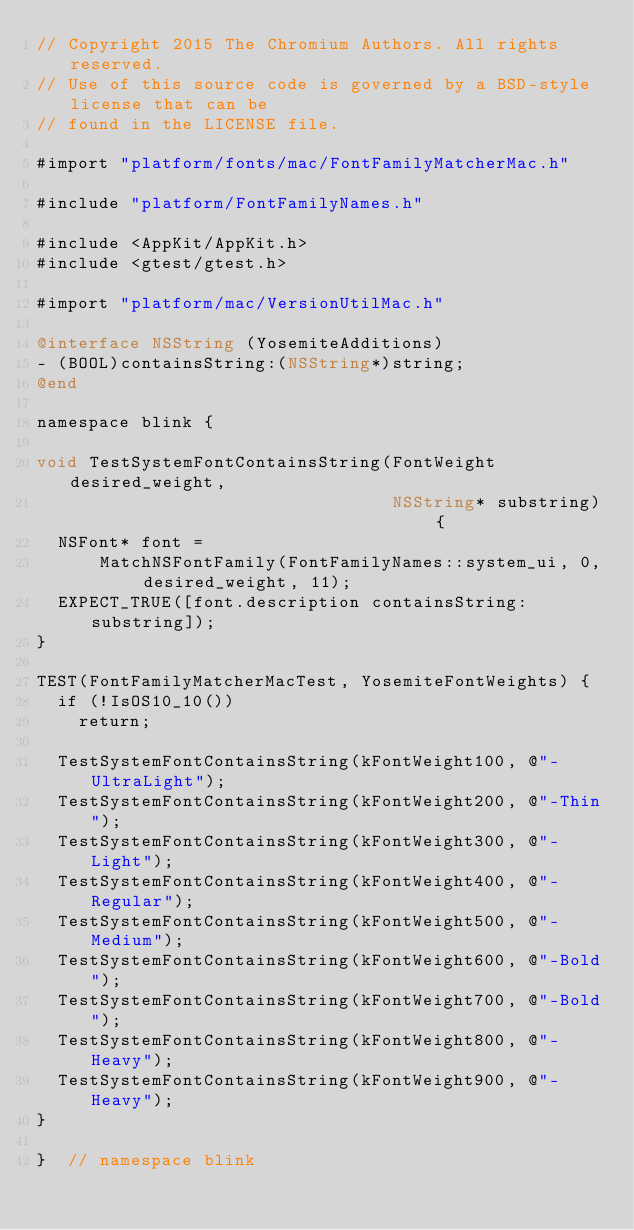<code> <loc_0><loc_0><loc_500><loc_500><_ObjectiveC_>// Copyright 2015 The Chromium Authors. All rights reserved.
// Use of this source code is governed by a BSD-style license that can be
// found in the LICENSE file.

#import "platform/fonts/mac/FontFamilyMatcherMac.h"

#include "platform/FontFamilyNames.h"

#include <AppKit/AppKit.h>
#include <gtest/gtest.h>

#import "platform/mac/VersionUtilMac.h"

@interface NSString (YosemiteAdditions)
- (BOOL)containsString:(NSString*)string;
@end

namespace blink {

void TestSystemFontContainsString(FontWeight desired_weight,
                                  NSString* substring) {
  NSFont* font =
      MatchNSFontFamily(FontFamilyNames::system_ui, 0, desired_weight, 11);
  EXPECT_TRUE([font.description containsString:substring]);
}

TEST(FontFamilyMatcherMacTest, YosemiteFontWeights) {
  if (!IsOS10_10())
    return;

  TestSystemFontContainsString(kFontWeight100, @"-UltraLight");
  TestSystemFontContainsString(kFontWeight200, @"-Thin");
  TestSystemFontContainsString(kFontWeight300, @"-Light");
  TestSystemFontContainsString(kFontWeight400, @"-Regular");
  TestSystemFontContainsString(kFontWeight500, @"-Medium");
  TestSystemFontContainsString(kFontWeight600, @"-Bold");
  TestSystemFontContainsString(kFontWeight700, @"-Bold");
  TestSystemFontContainsString(kFontWeight800, @"-Heavy");
  TestSystemFontContainsString(kFontWeight900, @"-Heavy");
}

}  // namespace blink
</code> 